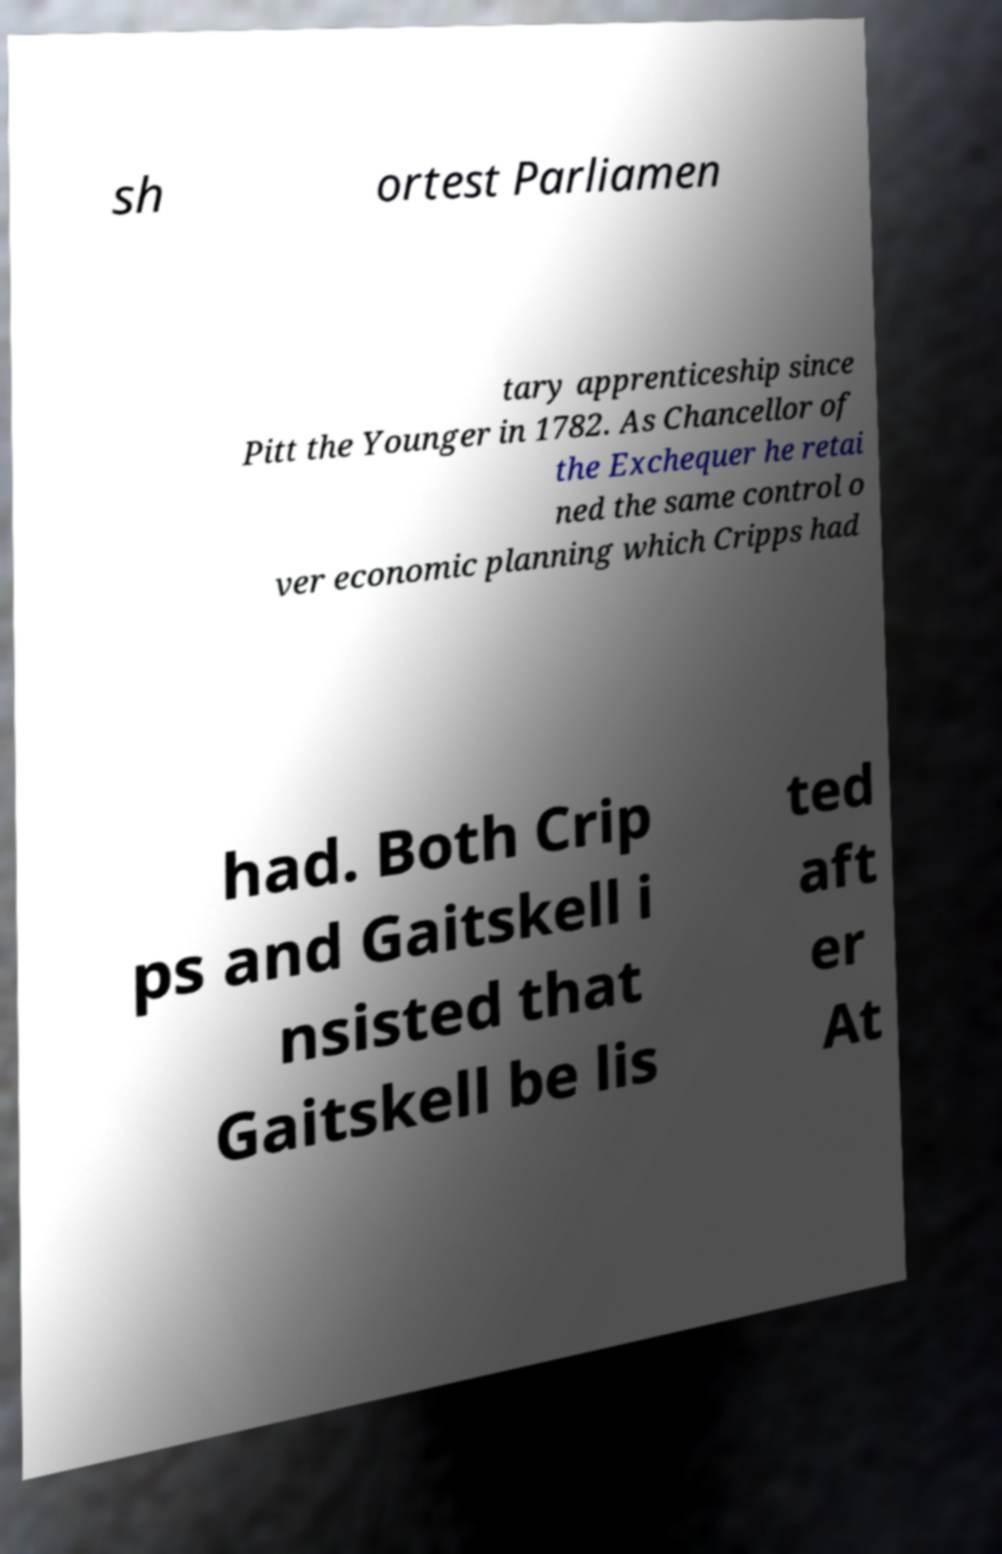Can you accurately transcribe the text from the provided image for me? sh ortest Parliamen tary apprenticeship since Pitt the Younger in 1782. As Chancellor of the Exchequer he retai ned the same control o ver economic planning which Cripps had had. Both Crip ps and Gaitskell i nsisted that Gaitskell be lis ted aft er At 